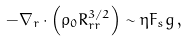<formula> <loc_0><loc_0><loc_500><loc_500>- \nabla _ { r } \cdot \left ( \rho _ { 0 } R ^ { 3 / 2 } _ { r r } \right ) \sim \eta F _ { s } g \, ,</formula> 